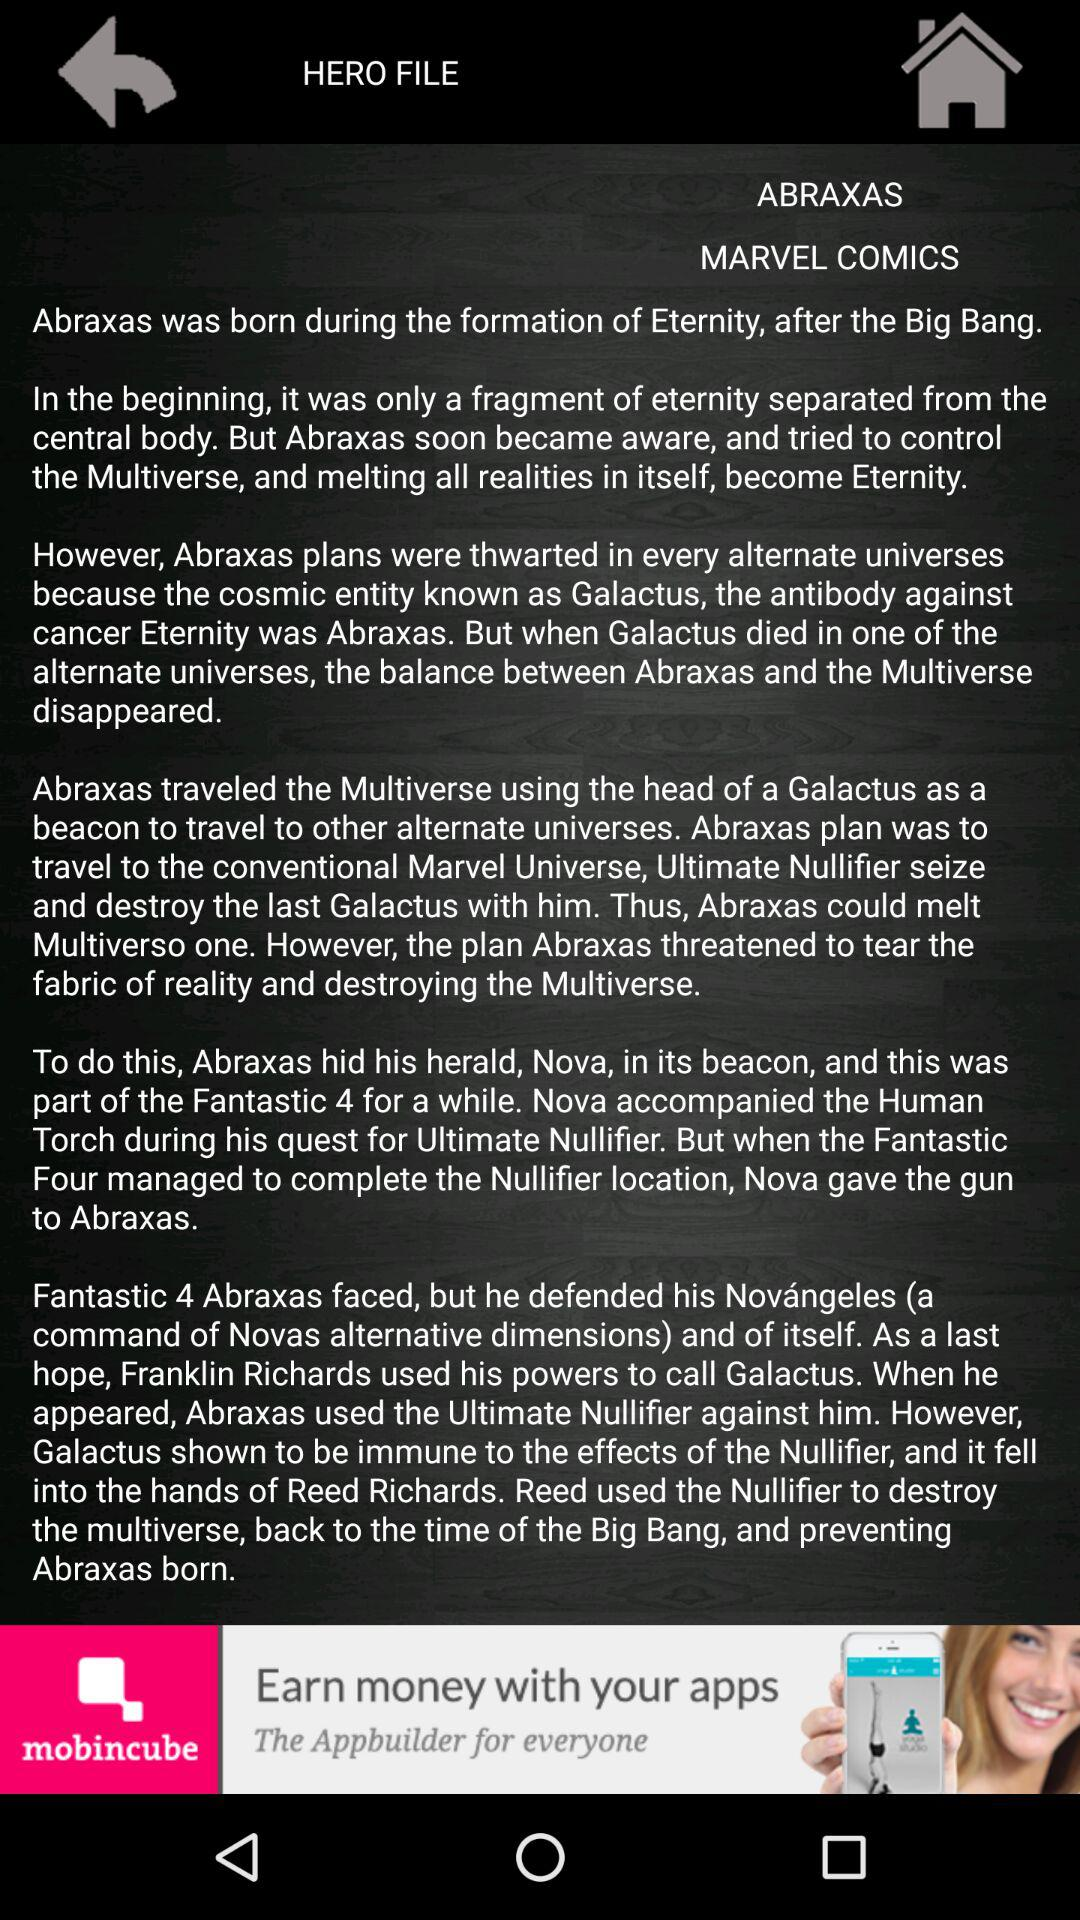What is the name of the character? The name of the character is "ABRAXAS". 